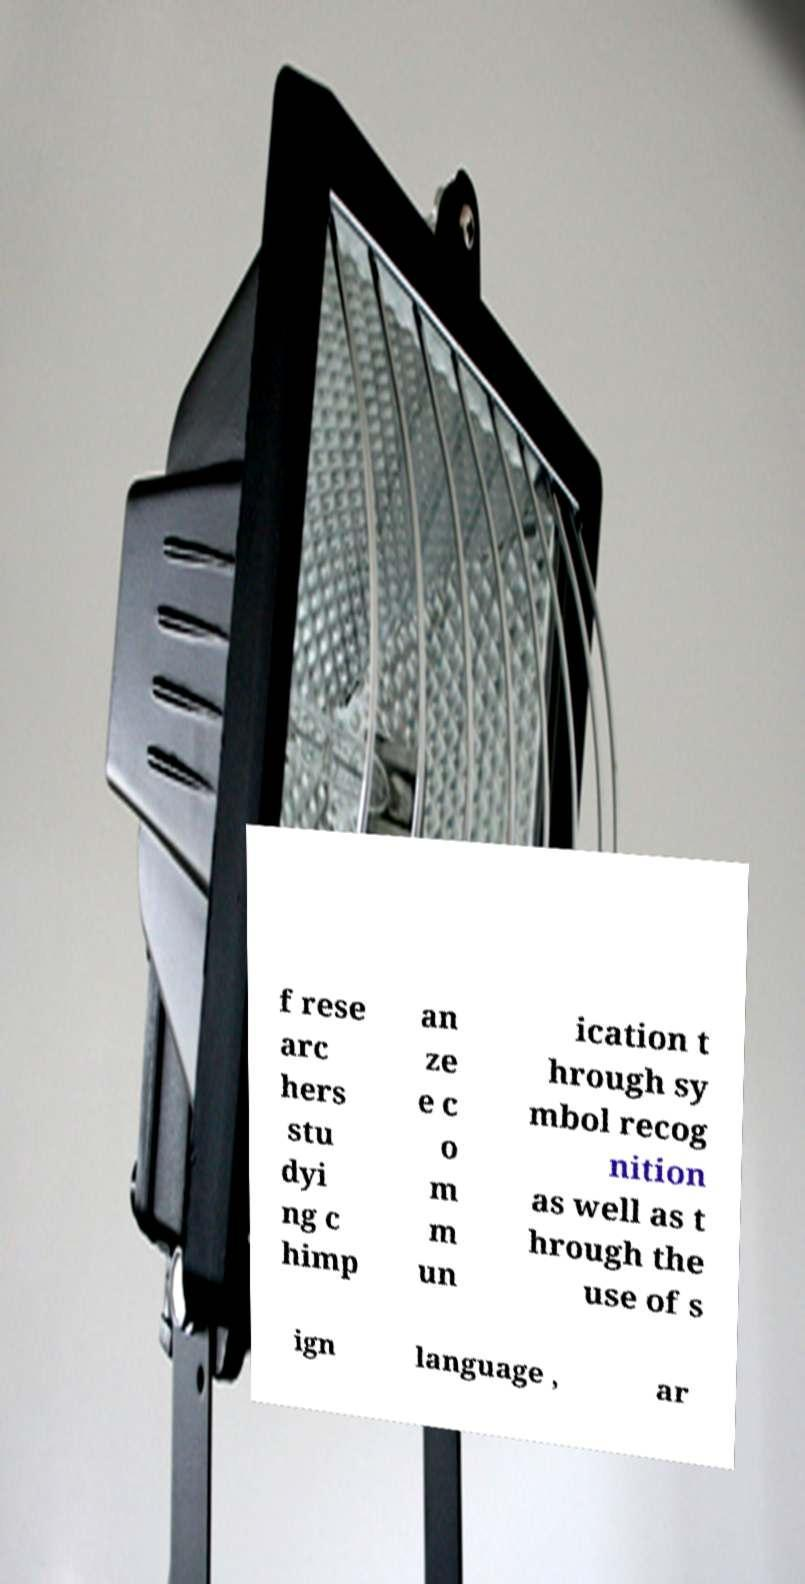Please identify and transcribe the text found in this image. f rese arc hers stu dyi ng c himp an ze e c o m m un ication t hrough sy mbol recog nition as well as t hrough the use of s ign language , ar 